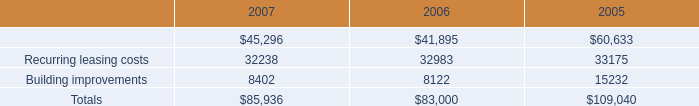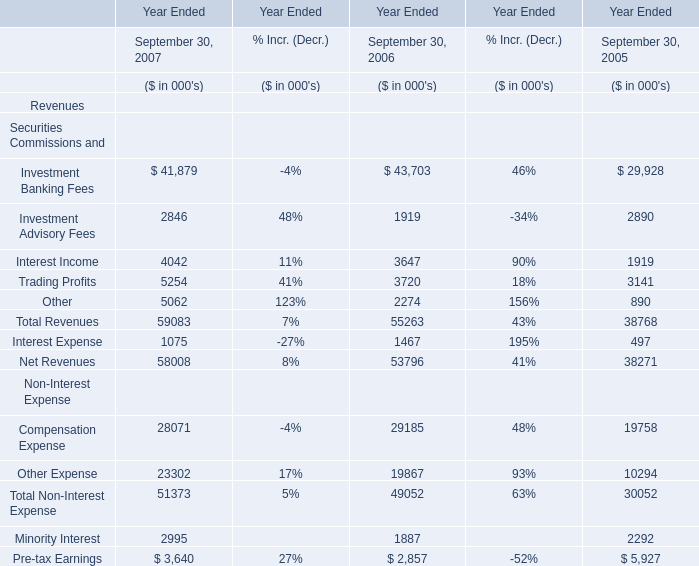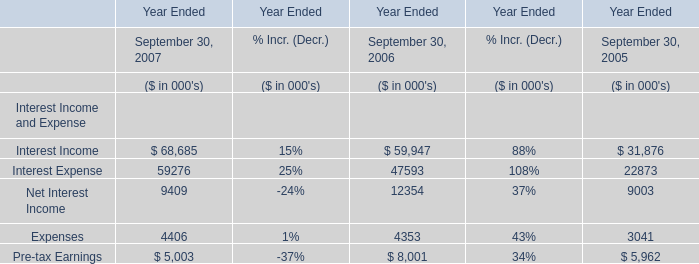What is the total value of Interest IncomeInterest ExpenseNet Interest Income Expenses in 2007? (in million) 
Computations: (((68685 + 59276) + 9409) + 4406)
Answer: 141776.0. 